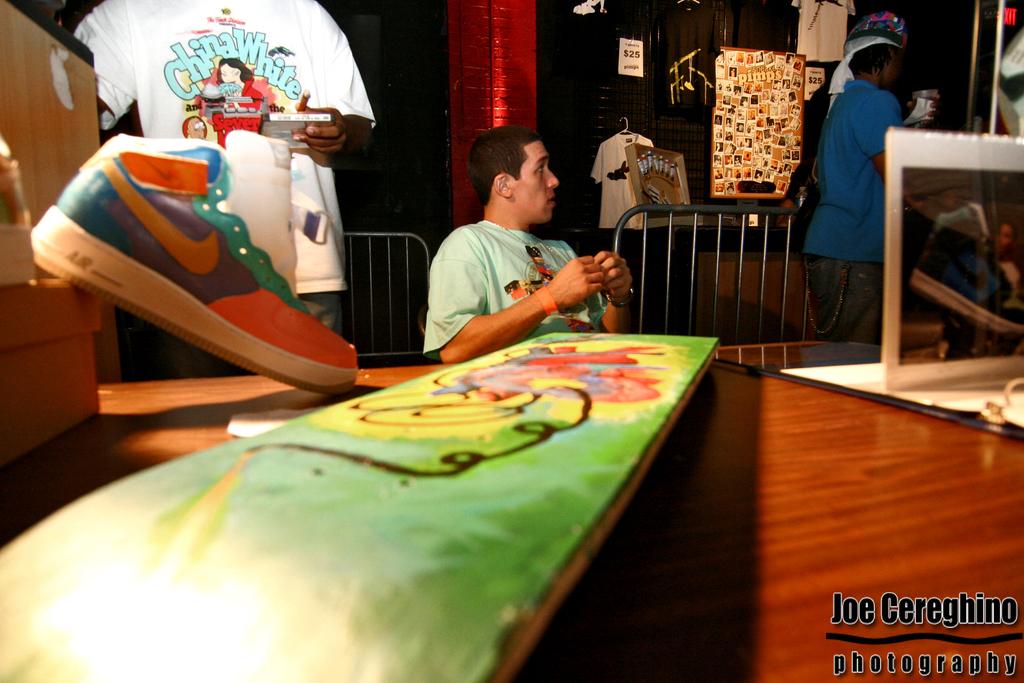What photography company took this photo?
Provide a short and direct response. Joe cereghino. What is the t shirt on the top left?
Give a very brief answer. China white. 